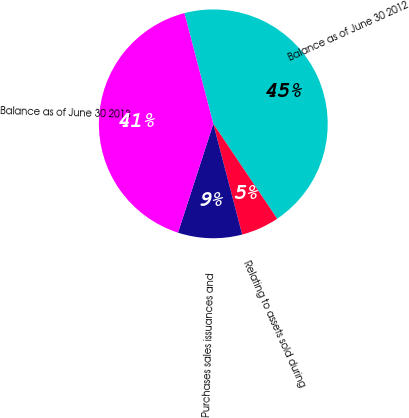Convert chart to OTSL. <chart><loc_0><loc_0><loc_500><loc_500><pie_chart><fcel>Balance as of June 30 2012<fcel>Relating to assets sold during<fcel>Purchases sales issuances and<fcel>Balance as of June 30 2013<nl><fcel>44.63%<fcel>5.37%<fcel>9.05%<fcel>40.95%<nl></chart> 